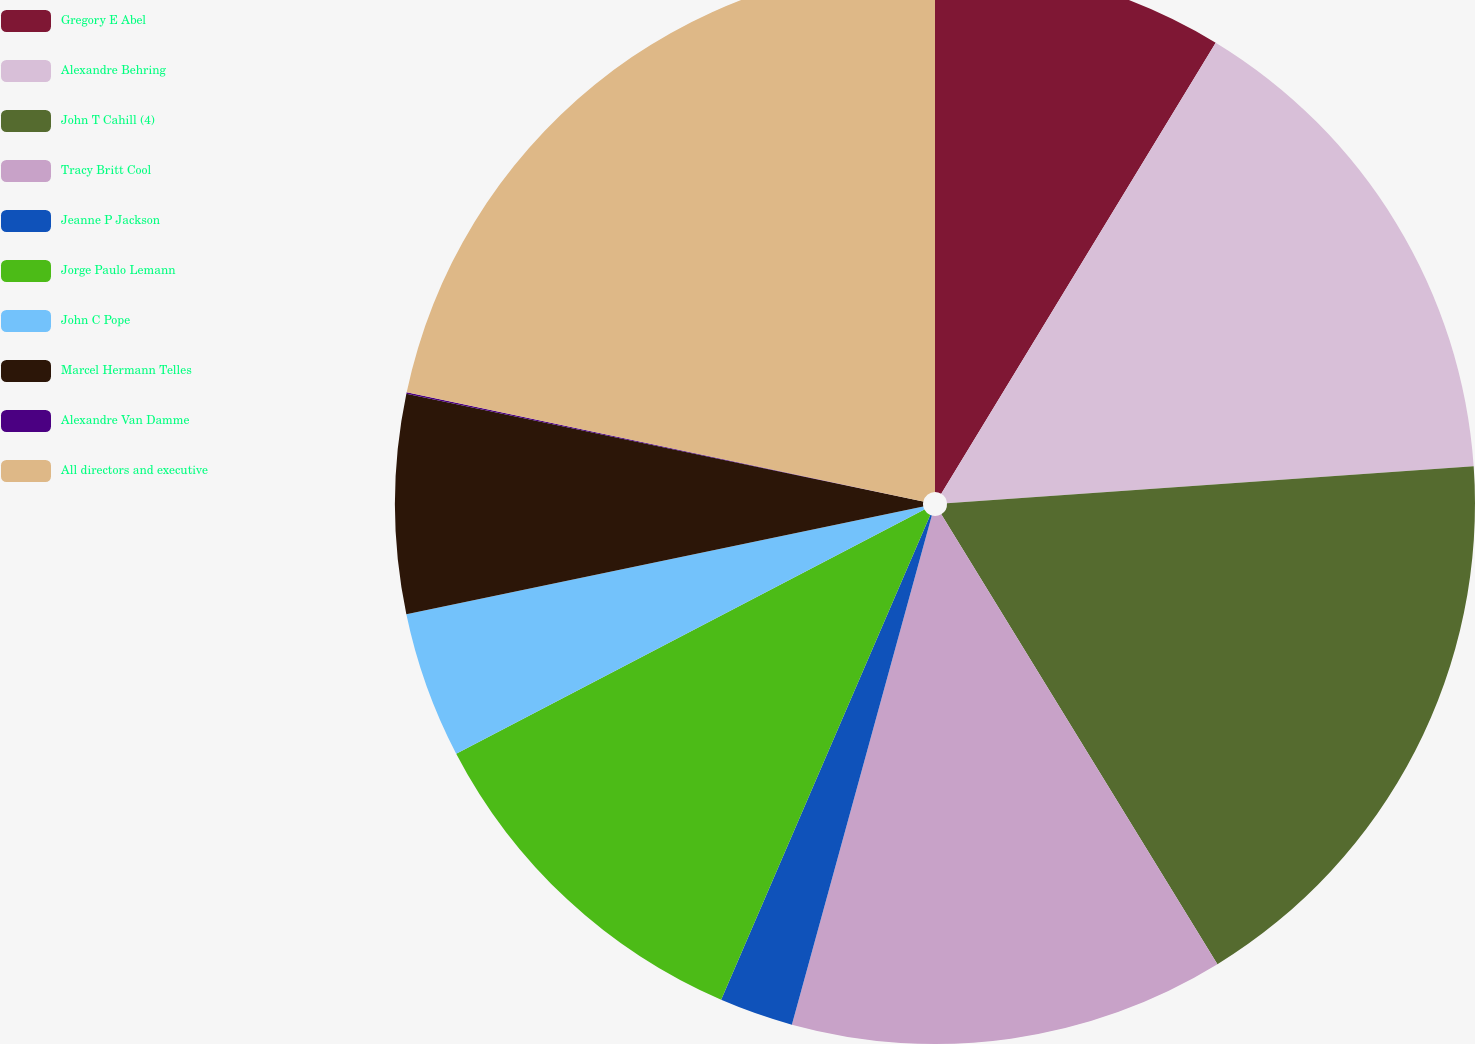<chart> <loc_0><loc_0><loc_500><loc_500><pie_chart><fcel>Gregory E Abel<fcel>Alexandre Behring<fcel>John T Cahill (4)<fcel>Tracy Britt Cool<fcel>Jeanne P Jackson<fcel>Jorge Paulo Lemann<fcel>John C Pope<fcel>Marcel Hermann Telles<fcel>Alexandre Van Damme<fcel>All directors and executive<nl><fcel>8.7%<fcel>15.19%<fcel>17.35%<fcel>13.03%<fcel>2.21%<fcel>10.87%<fcel>4.38%<fcel>6.54%<fcel>0.05%<fcel>21.68%<nl></chart> 